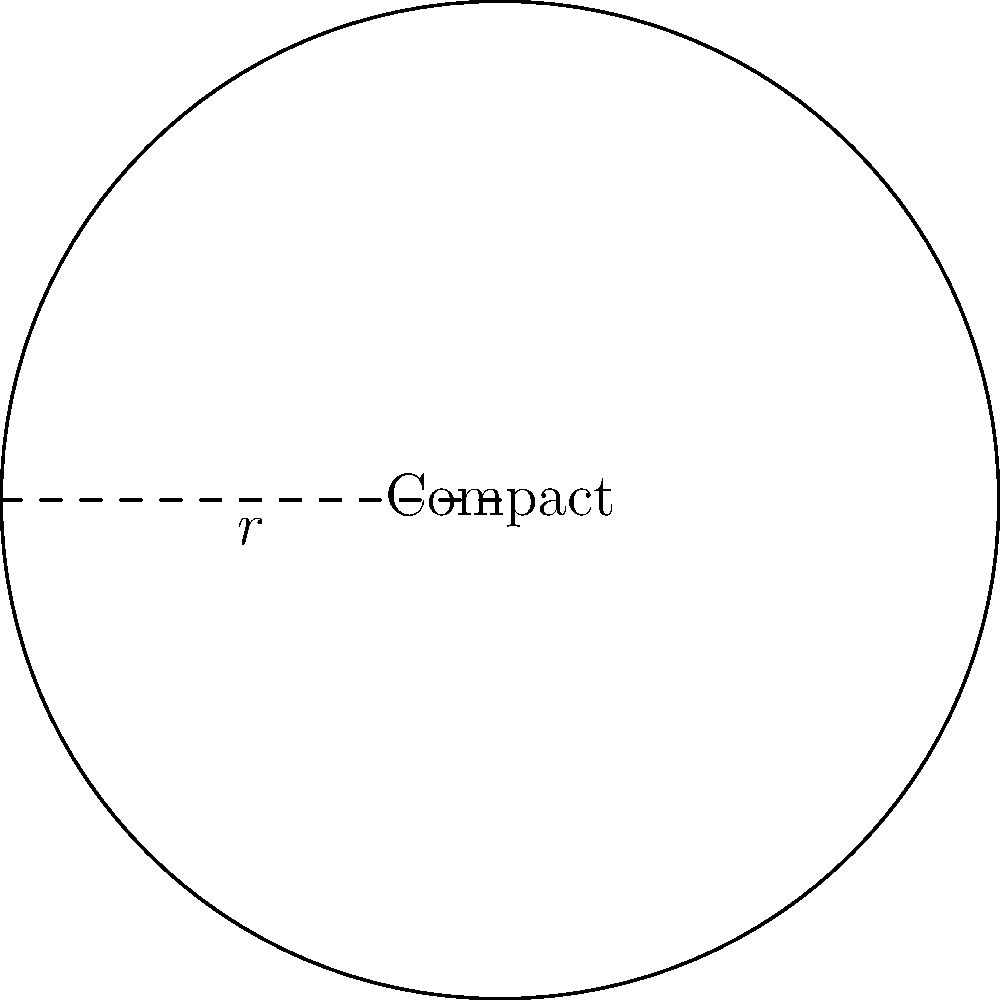Your favorite celebrity makeup brand has released a limited edition circular compact in honor of Anna Nicole Smith. The compact has a radius of 3 inches. What is the perimeter of this collectible item? Let's calculate the perimeter of this circular compact step-by-step:

1) The formula for the perimeter (circumference) of a circle is:
   $$P = 2\pi r$$
   where $P$ is the perimeter, $\pi$ is pi, and $r$ is the radius.

2) We're given that the radius is 3 inches.

3) Let's substitute these values into our formula:
   $$P = 2\pi(3)$$

4) Simplify:
   $$P = 6\pi$$

5) If we want to give a decimal approximation, we can use $\pi \approx 3.14159$:
   $$P \approx 6(3.14159) \approx 18.85 \text{ inches}$$

So, the perimeter of your Anna Nicole Smith commemorative compact is $6\pi$ inches, or approximately 18.85 inches.
Answer: $6\pi$ inches 